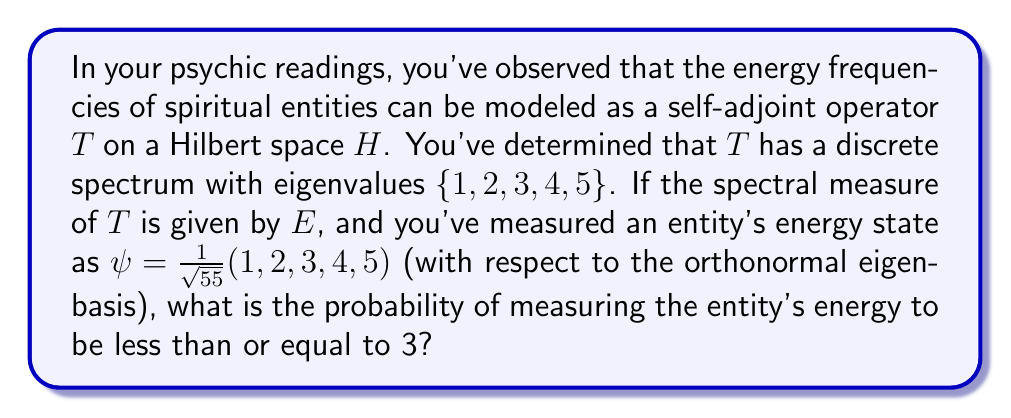Help me with this question. To solve this problem, we'll use spectral theory and the given information:

1) The operator $T$ has a discrete spectrum $\{1, 2, 3, 4, 5\}$.

2) The spectral measure $E$ corresponds to this spectrum.

3) The entity's energy state is given by $\psi = \frac{1}{\sqrt{55}}(1, 2, 3, 4, 5)$.

The probability of measuring the energy to be less than or equal to 3 is given by:

$$P(T \leq 3) = \langle E((-\infty, 3])\psi, \psi \rangle$$

Given the discrete spectrum, this is equivalent to:

$$P(T \leq 3) = \langle (E(\{1\}) + E(\{2\}) + E(\{3\}))\psi, \psi \rangle$$

Each $E(\{k\})$ is the projection onto the eigenspace of eigenvalue $k$. In the given orthonormal eigenbasis, these are simply:

$$E(\{1\}) = \begin{pmatrix} 1 & 0 & 0 & 0 & 0 \\ 0 & 0 & 0 & 0 & 0 \\ 0 & 0 & 0 & 0 & 0 \\ 0 & 0 & 0 & 0 & 0 \\ 0 & 0 & 0 & 0 & 0 \end{pmatrix}$$

$$E(\{2\}) = \begin{pmatrix} 0 & 0 & 0 & 0 & 0 \\ 0 & 1 & 0 & 0 & 0 \\ 0 & 0 & 0 & 0 & 0 \\ 0 & 0 & 0 & 0 & 0 \\ 0 & 0 & 0 & 0 & 0 \end{pmatrix}$$

$$E(\{3\}) = \begin{pmatrix} 0 & 0 & 0 & 0 & 0 \\ 0 & 0 & 0 & 0 & 0 \\ 0 & 0 & 1 & 0 & 0 \\ 0 & 0 & 0 & 0 & 0 \\ 0 & 0 & 0 & 0 & 0 \end{pmatrix}$$

Applying these to $\psi$:

$$(E(\{1\}) + E(\{2\}) + E(\{3\}))\psi = \frac{1}{\sqrt{55}}(1, 2, 3, 0, 0)$$

Now, we calculate the inner product:

$$\begin{align}
P(T \leq 3) &= \left\langle \frac{1}{\sqrt{55}}(1, 2, 3, 0, 0), \frac{1}{\sqrt{55}}(1, 2, 3, 4, 5) \right\rangle \\
&= \frac{1}{55}(1 \cdot 1 + 2 \cdot 2 + 3 \cdot 3 + 0 \cdot 4 + 0 \cdot 5) \\
&= \frac{1}{55}(1 + 4 + 9) \\
&= \frac{14}{55}
\end{align}$$
Answer: $\frac{14}{55}$ or approximately $0.2545$ (25.45%) 